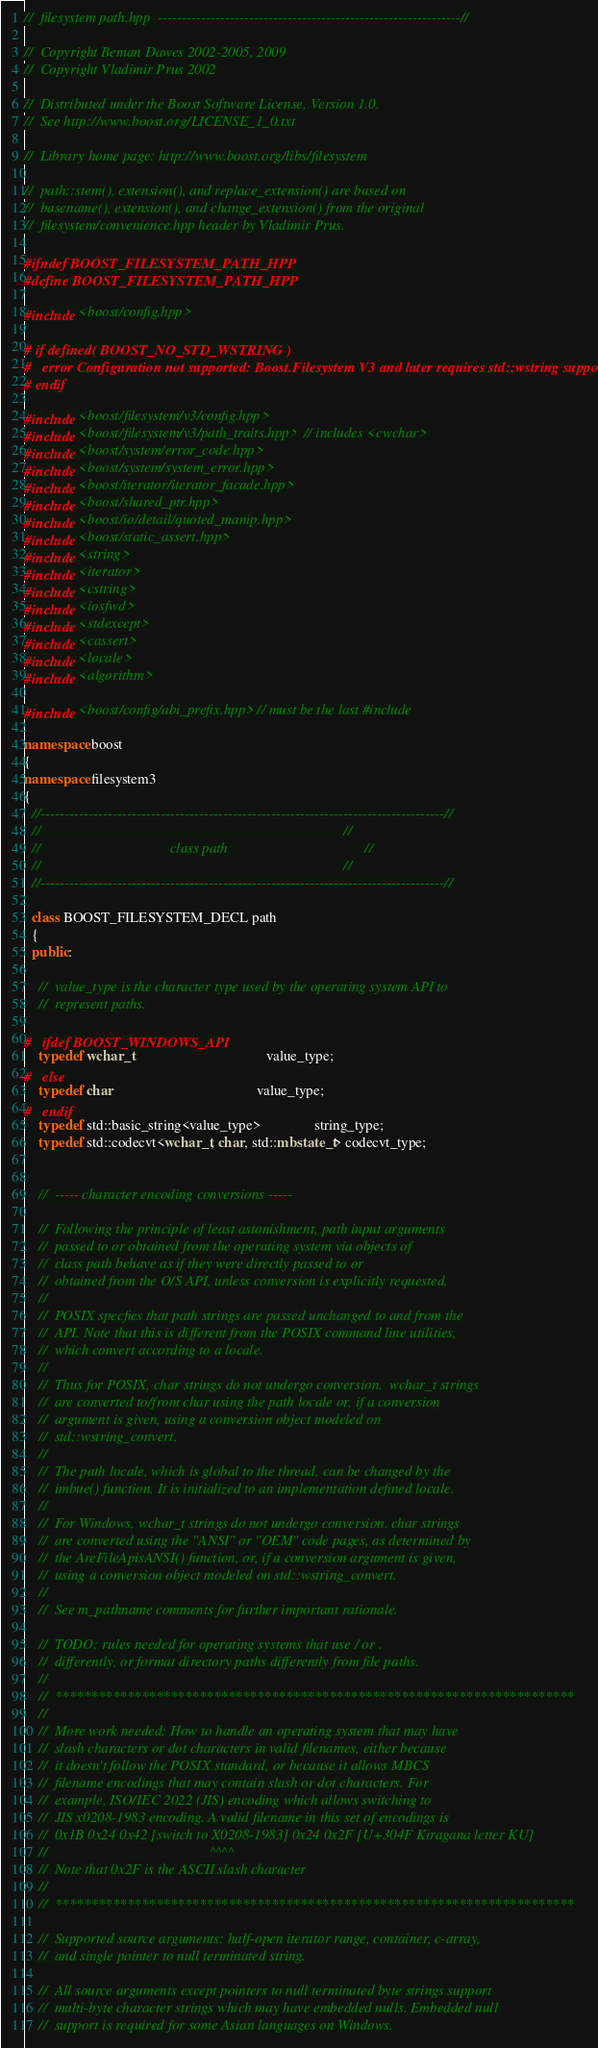<code> <loc_0><loc_0><loc_500><loc_500><_C++_>//  filesystem path.hpp  ---------------------------------------------------------------//

//  Copyright Beman Dawes 2002-2005, 2009
//  Copyright Vladimir Prus 2002

//  Distributed under the Boost Software License, Version 1.0.
//  See http://www.boost.org/LICENSE_1_0.txt

//  Library home page: http://www.boost.org/libs/filesystem

//  path::stem(), extension(), and replace_extension() are based on
//  basename(), extension(), and change_extension() from the original
//  filesystem/convenience.hpp header by Vladimir Prus.

#ifndef BOOST_FILESYSTEM_PATH_HPP
#define BOOST_FILESYSTEM_PATH_HPP

#include <boost/config.hpp>

# if defined( BOOST_NO_STD_WSTRING )
#   error Configuration not supported: Boost.Filesystem V3 and later requires std::wstring support
# endif

#include <boost/filesystem/v3/config.hpp>
#include <boost/filesystem/v3/path_traits.hpp>  // includes <cwchar>
#include <boost/system/error_code.hpp>
#include <boost/system/system_error.hpp>
#include <boost/iterator/iterator_facade.hpp>
#include <boost/shared_ptr.hpp>
#include <boost/io/detail/quoted_manip.hpp>
#include <boost/static_assert.hpp>
#include <string>
#include <iterator>
#include <cstring>
#include <iosfwd>
#include <stdexcept>
#include <cassert>
#include <locale>
#include <algorithm>

#include <boost/config/abi_prefix.hpp> // must be the last #include

namespace boost
{
namespace filesystem3
{
  //------------------------------------------------------------------------------------//
  //                                                                                    //
  //                                    class path                                      //
  //                                                                                    //
  //------------------------------------------------------------------------------------//

  class BOOST_FILESYSTEM_DECL path
  {
  public:

    //  value_type is the character type used by the operating system API to
    //  represent paths.

#   ifdef BOOST_WINDOWS_API
    typedef wchar_t                                     value_type;
#   else 
    typedef char                                        value_type;
#   endif
    typedef std::basic_string<value_type>               string_type;  
    typedef std::codecvt<wchar_t, char, std::mbstate_t> codecvt_type;


    //  ----- character encoding conversions -----

    //  Following the principle of least astonishment, path input arguments
    //  passed to or obtained from the operating system via objects of
    //  class path behave as if they were directly passed to or
    //  obtained from the O/S API, unless conversion is explicitly requested.
    //
    //  POSIX specfies that path strings are passed unchanged to and from the
    //  API. Note that this is different from the POSIX command line utilities,
    //  which convert according to a locale.
    //
    //  Thus for POSIX, char strings do not undergo conversion.  wchar_t strings
    //  are converted to/from char using the path locale or, if a conversion
    //  argument is given, using a conversion object modeled on
    //  std::wstring_convert.
    //
    //  The path locale, which is global to the thread, can be changed by the
    //  imbue() function. It is initialized to an implementation defined locale.
    //  
    //  For Windows, wchar_t strings do not undergo conversion. char strings
    //  are converted using the "ANSI" or "OEM" code pages, as determined by
    //  the AreFileApisANSI() function, or, if a conversion argument is given,
    //  using a conversion object modeled on std::wstring_convert.
    //
    //  See m_pathname comments for further important rationale.

    //  TODO: rules needed for operating systems that use / or .
    //  differently, or format directory paths differently from file paths. 
    //
    //  ************************************************************************
    //
    //  More work needed: How to handle an operating system that may have
    //  slash characters or dot characters in valid filenames, either because
    //  it doesn't follow the POSIX standard, or because it allows MBCS
    //  filename encodings that may contain slash or dot characters. For
    //  example, ISO/IEC 2022 (JIS) encoding which allows switching to
    //  JIS x0208-1983 encoding. A valid filename in this set of encodings is
    //  0x1B 0x24 0x42 [switch to X0208-1983] 0x24 0x2F [U+304F Kiragana letter KU]
    //                                             ^^^^
    //  Note that 0x2F is the ASCII slash character
    //
    //  ************************************************************************

    //  Supported source arguments: half-open iterator range, container, c-array,
    //  and single pointer to null terminated string.

    //  All source arguments except pointers to null terminated byte strings support
    //  multi-byte character strings which may have embedded nulls. Embedded null
    //  support is required for some Asian languages on Windows.
</code> 